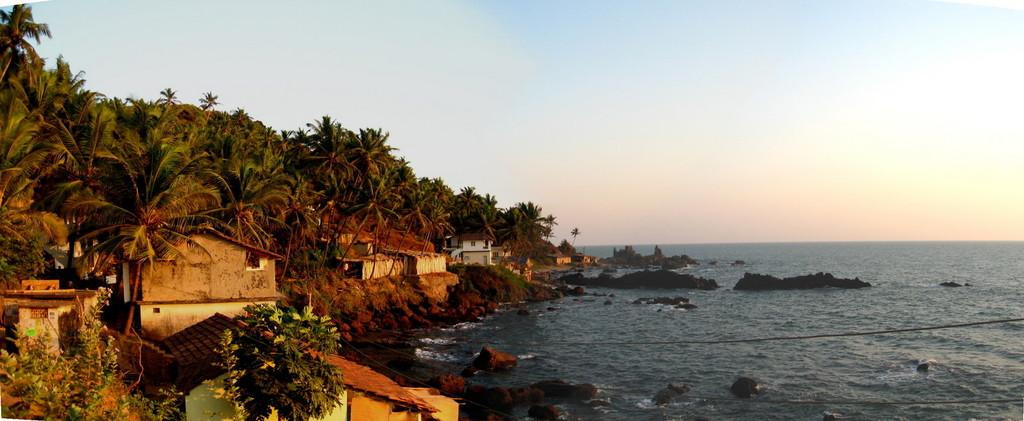What type of structures can be seen in the image? There are buildings in the image. What natural elements are present in the image? There are trees and water visible in the image. What type of terrain is depicted in the image? There are rocks in the image, indicating a rocky terrain. What type of lunch is being shared between the buildings in the image? There is no lunch depicted in the image; it features buildings, trees, water, and rocks. 